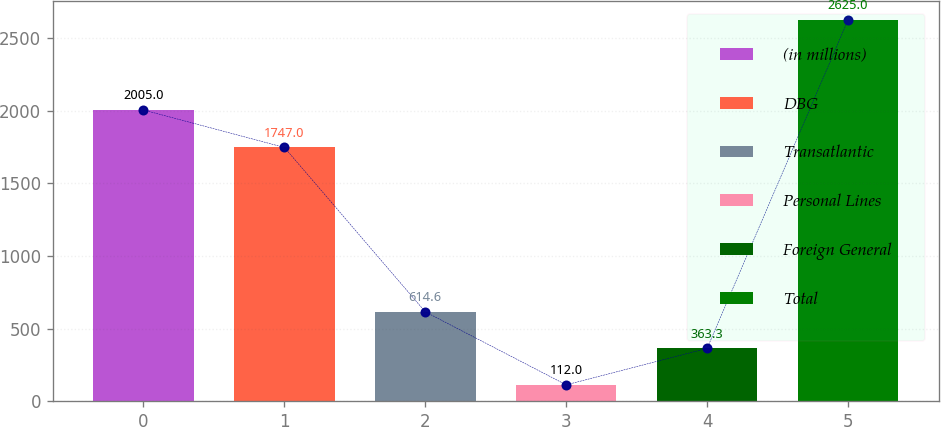Convert chart to OTSL. <chart><loc_0><loc_0><loc_500><loc_500><bar_chart><fcel>(in millions)<fcel>DBG<fcel>Transatlantic<fcel>Personal Lines<fcel>Foreign General<fcel>Total<nl><fcel>2005<fcel>1747<fcel>614.6<fcel>112<fcel>363.3<fcel>2625<nl></chart> 